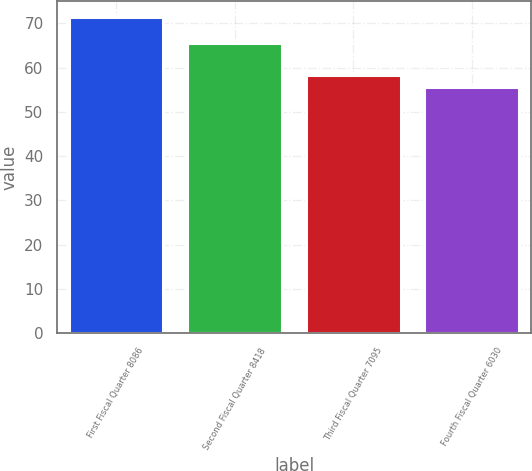Convert chart. <chart><loc_0><loc_0><loc_500><loc_500><bar_chart><fcel>First Fiscal Quarter 8086<fcel>Second Fiscal Quarter 8418<fcel>Third Fiscal Quarter 7095<fcel>Fourth Fiscal Quarter 6030<nl><fcel>71.4<fcel>65.61<fcel>58.29<fcel>55.65<nl></chart> 